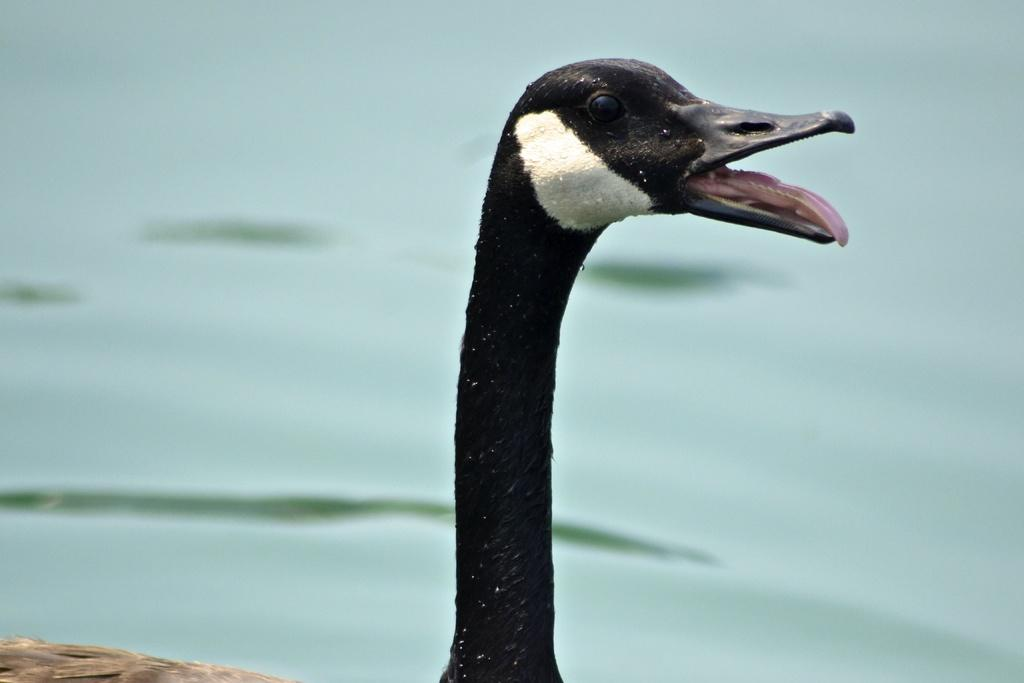What type of animal is in the water in the image? There is a duck in the water in the image. Can you describe the location of the duck in the image? The duck is located at the center of the image. What type of bucket is the duck using to collect knowledge in the image? There is no bucket or knowledge present in the image; it features a duck in the water. 